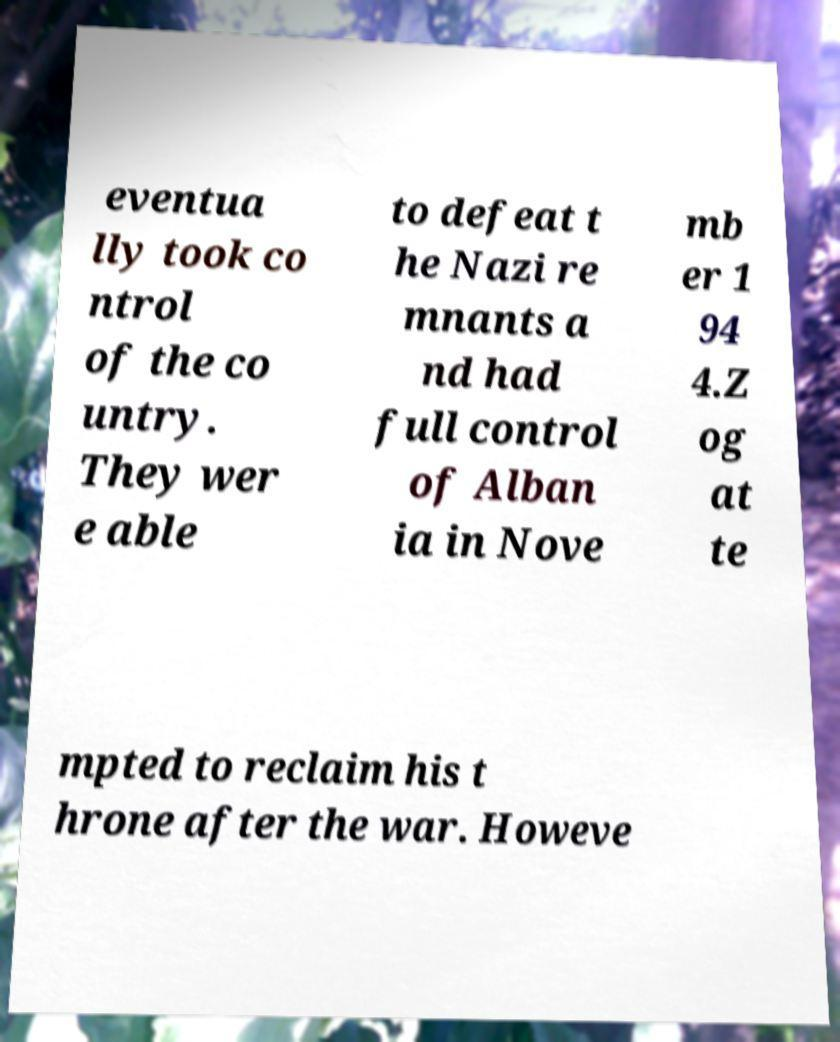I need the written content from this picture converted into text. Can you do that? eventua lly took co ntrol of the co untry. They wer e able to defeat t he Nazi re mnants a nd had full control of Alban ia in Nove mb er 1 94 4.Z og at te mpted to reclaim his t hrone after the war. Howeve 